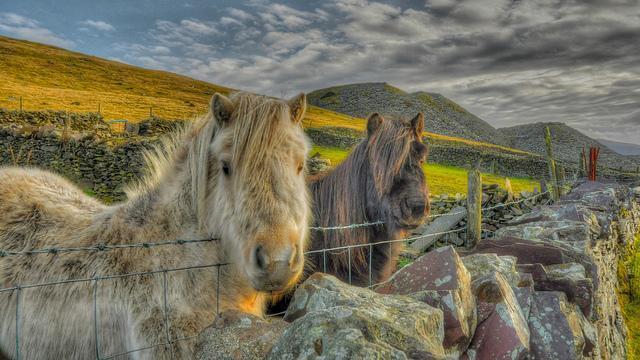How many horses are visible?
Give a very brief answer. 2. How many cows can you see?
Give a very brief answer. 0. 